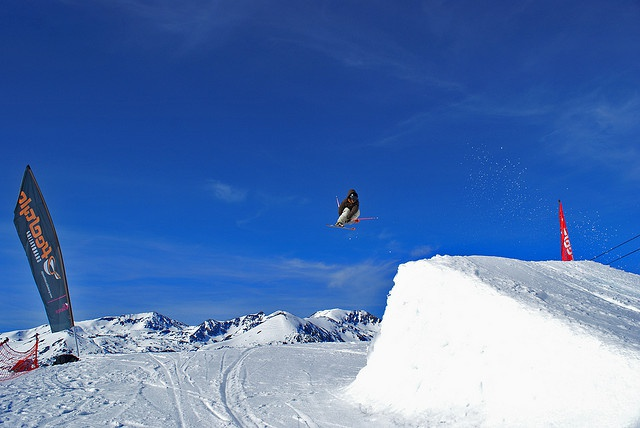Describe the objects in this image and their specific colors. I can see people in darkblue, black, gray, darkgray, and maroon tones and skis in darkblue, gray, blue, and brown tones in this image. 